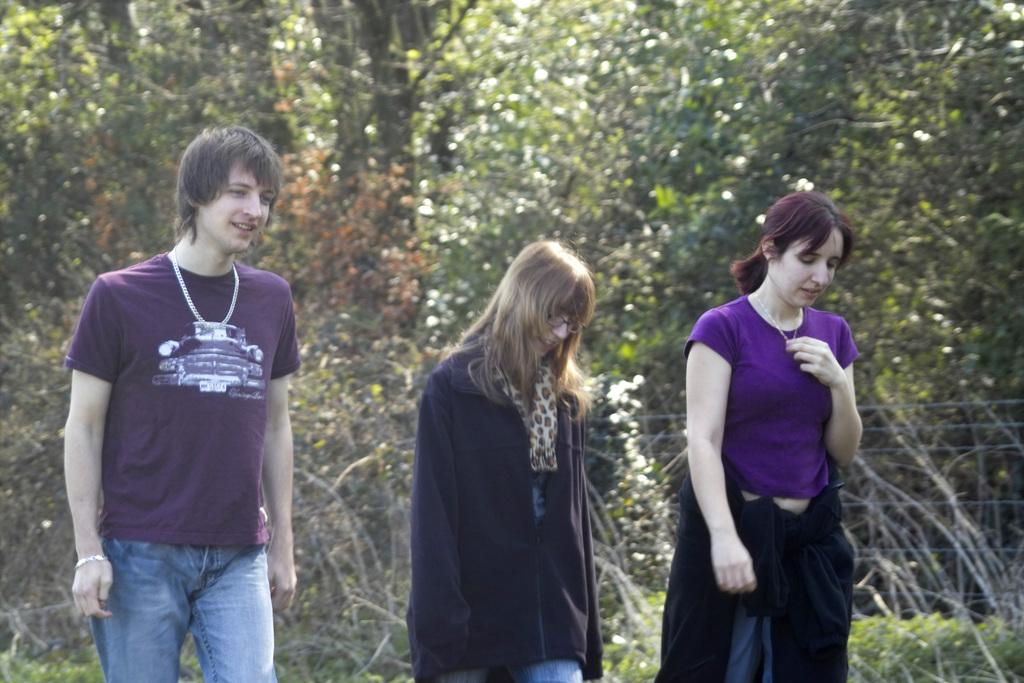How many people are in the image? There are two women and a man in the image. What is the man doing in the image? The man is standing. What can be seen in the background of the image? There appears to be a fence and trees in the background of the image. What is the condition of the trees in the image? The trees have branches and leaves. Where is the throne located in the image? There is no throne present in the image. How many houses can be seen in the image? There are no houses visible in the image. 